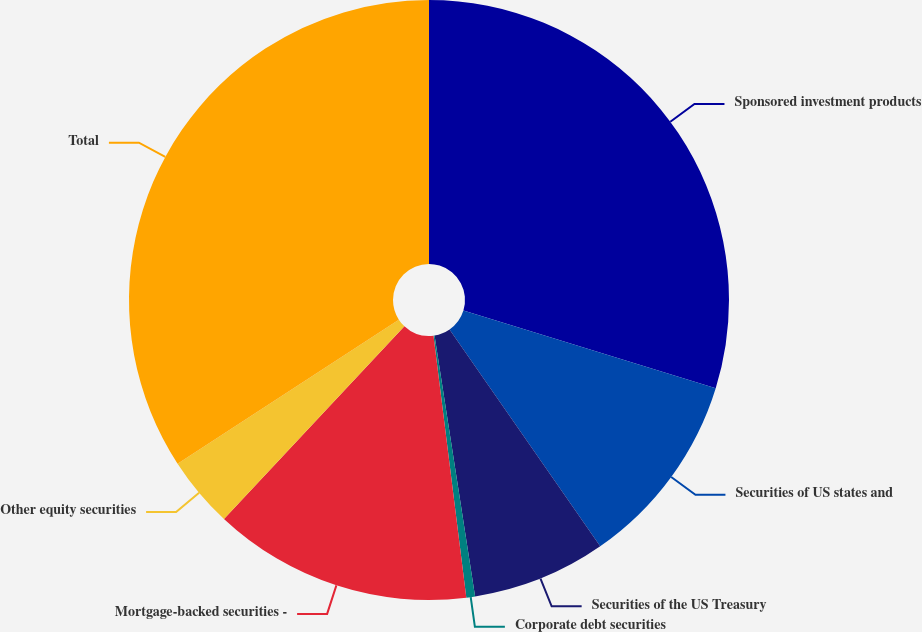<chart> <loc_0><loc_0><loc_500><loc_500><pie_chart><fcel>Sponsored investment products<fcel>Securities of US states and<fcel>Securities of the US Treasury<fcel>Corporate debt securities<fcel>Mortgage-backed securities -<fcel>Other equity securities<fcel>Total<nl><fcel>29.75%<fcel>10.58%<fcel>7.21%<fcel>0.47%<fcel>13.96%<fcel>3.84%<fcel>34.18%<nl></chart> 